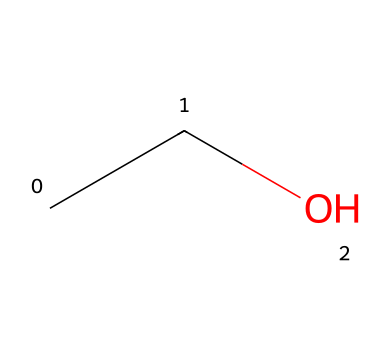What is the name of this chemical? The chemical represented by the SMILES "CCO" is commonly known as ethanol, which is a two-carbon alcohol.
Answer: ethanol How many carbon atoms are present in this molecule? By analyzing the SMILES representation "CCO," we can count the carbon atoms denoted by "C." There are two "C" letters present, indicating two carbon atoms.
Answer: 2 What type of functional group is present in ethanol? The "O" in the SMILES "CCO" indicates the presence of a hydroxyl (-OH) group, which is characteristic of alcohols. Hence, ethanol has an alcohol functional group.
Answer: alcohol What is the total number of hydrogen atoms in this molecule? In the SMILES "CCO," each carbon typically bonds with enough hydrogen atoms to fulfill its tetravalent nature (4 bonds). The two carbons account for four hydrogen atoms and the -OH adds one more hydrogen atom, totaling five hydrogen atoms.
Answer: 6 What is the molecular weight of ethanol? To determine the molecular weight, we sum the atomic weights of the components: Carbon (C) is approximately 12.01 amu (2*12.01 = 24.02), Hydrogen (H) is approximately 1.008 amu (6*1.008 = 6.048), and Oxygen (O) is approximately 16.00 amu (1*16.00=16.00). The total weight is approximately 46.068 amu.
Answer: 46.07 Is ethanol considered a polar solvent? Due to the presence of the hydroxyl group (-OH) in its structure, ethanol exhibits polarity, as this group engages in hydrogen bonding with water, making it a polar solvent.
Answer: yes Can ethanol be used as a solvent for organic compounds? Ethanol's ability to dissolve a wide range of organic compounds due to its polar and non-polar characteristics allows it to effectively serve as a solvent in various chemical reactions.
Answer: yes 